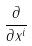<formula> <loc_0><loc_0><loc_500><loc_500>\frac { \partial } { \partial x ^ { i } }</formula> 